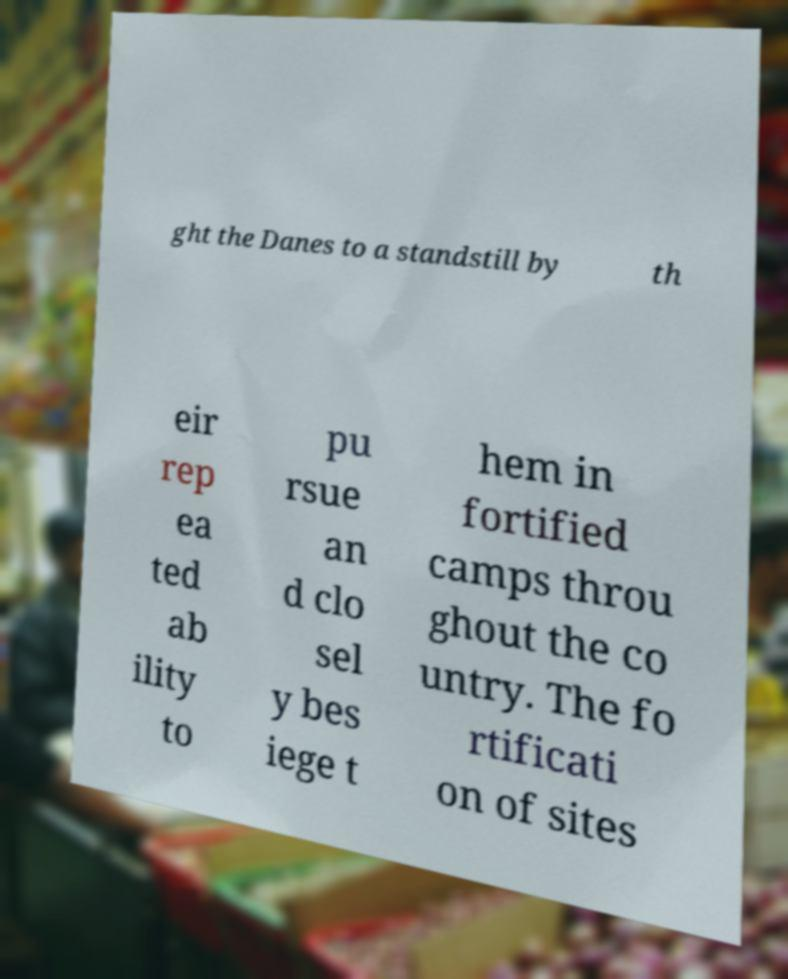For documentation purposes, I need the text within this image transcribed. Could you provide that? ght the Danes to a standstill by th eir rep ea ted ab ility to pu rsue an d clo sel y bes iege t hem in fortified camps throu ghout the co untry. The fo rtificati on of sites 